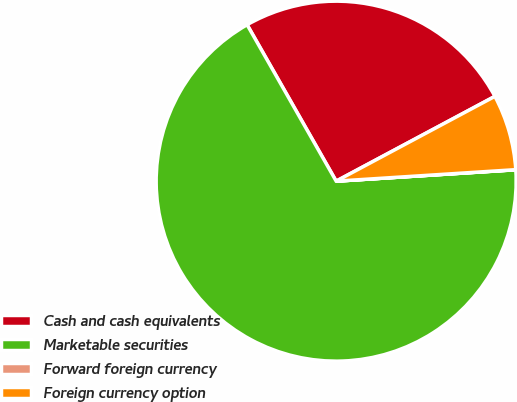Convert chart to OTSL. <chart><loc_0><loc_0><loc_500><loc_500><pie_chart><fcel>Cash and cash equivalents<fcel>Marketable securities<fcel>Forward foreign currency<fcel>Foreign currency option<nl><fcel>25.43%<fcel>67.77%<fcel>0.01%<fcel>6.79%<nl></chart> 